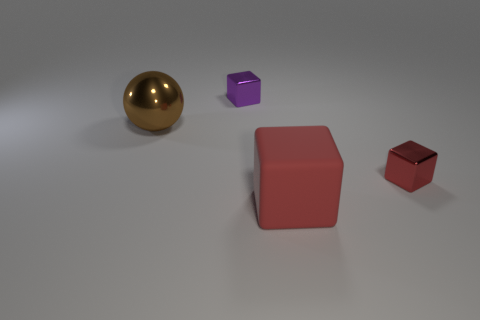What shape is the brown metallic thing that is the same size as the matte cube?
Offer a terse response. Sphere. There is a big rubber thing that is the same shape as the red metal thing; what is its color?
Provide a succinct answer. Red. What number of things are yellow balls or red shiny cubes?
Provide a succinct answer. 1. Do the shiny thing that is in front of the large brown metallic object and the thing behind the big shiny object have the same shape?
Give a very brief answer. Yes. The big metallic object left of the big matte object has what shape?
Your answer should be compact. Sphere. Are there the same number of big balls that are on the right side of the big brown ball and tiny things to the right of the big rubber cube?
Your answer should be compact. No. How many objects are either big green shiny spheres or tiny metallic things that are to the right of the red rubber block?
Offer a terse response. 1. What is the shape of the object that is behind the rubber cube and in front of the brown thing?
Offer a terse response. Cube. What material is the large thing that is on the right side of the tiny shiny object that is behind the big ball made of?
Keep it short and to the point. Rubber. Does the thing behind the shiny ball have the same material as the large ball?
Your answer should be very brief. Yes. 